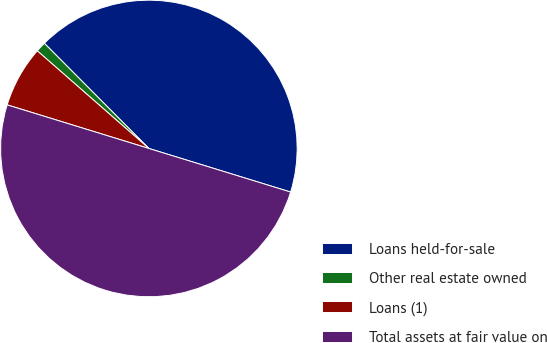<chart> <loc_0><loc_0><loc_500><loc_500><pie_chart><fcel>Loans held-for-sale<fcel>Other real estate owned<fcel>Loans (1)<fcel>Total assets at fair value on<nl><fcel>42.2%<fcel>1.11%<fcel>6.69%<fcel>50.0%<nl></chart> 